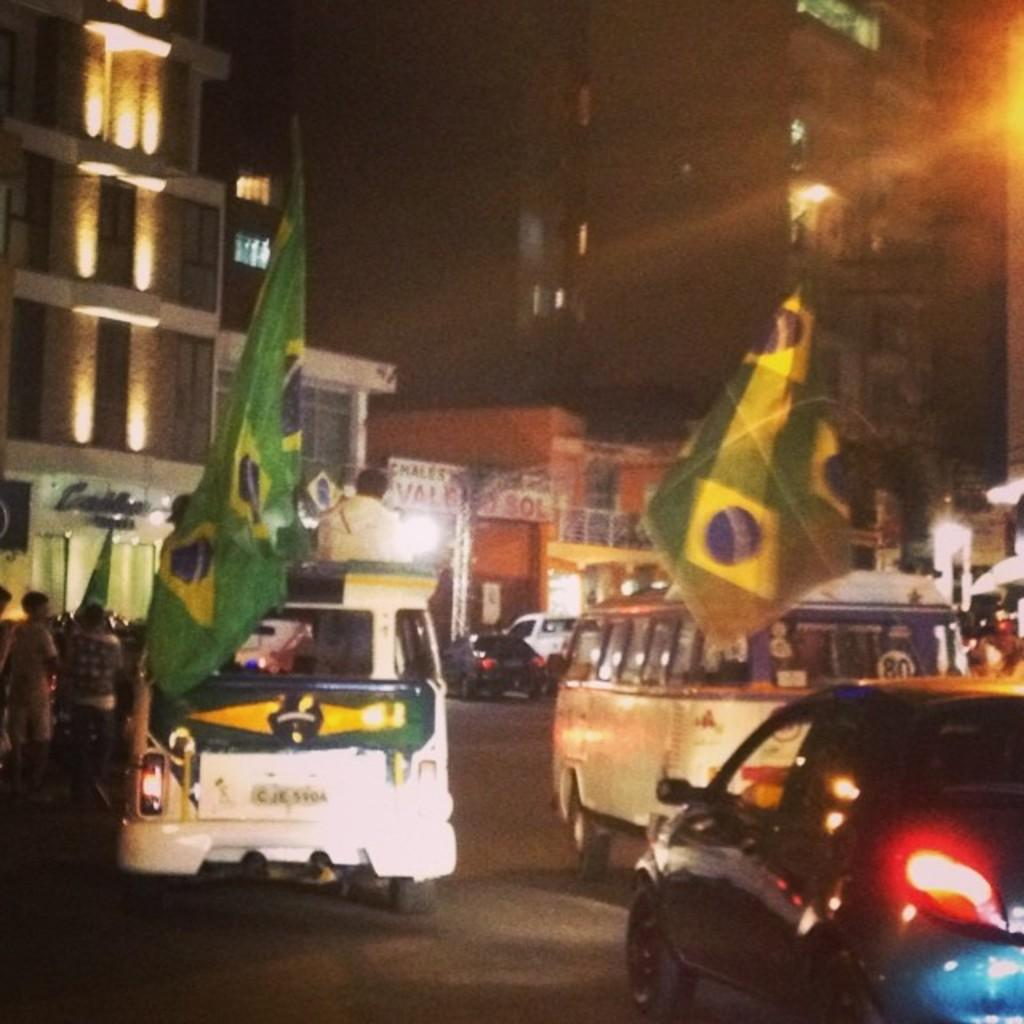<image>
Share a concise interpretation of the image provided. CJK 5904 is displayed on the rear license plate of the van. 